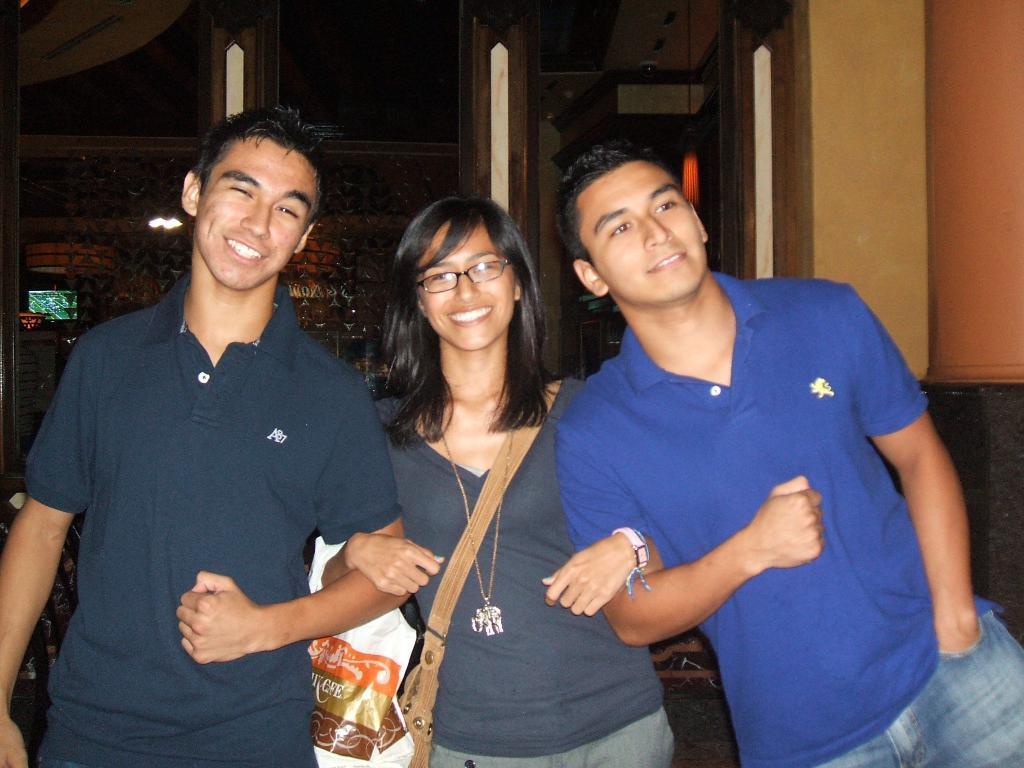Can you describe this image briefly? This image is taken indoors. In the middle of the image two men and a woman are standing on the floor and they are with smiling faces. In the background there is a wall. 